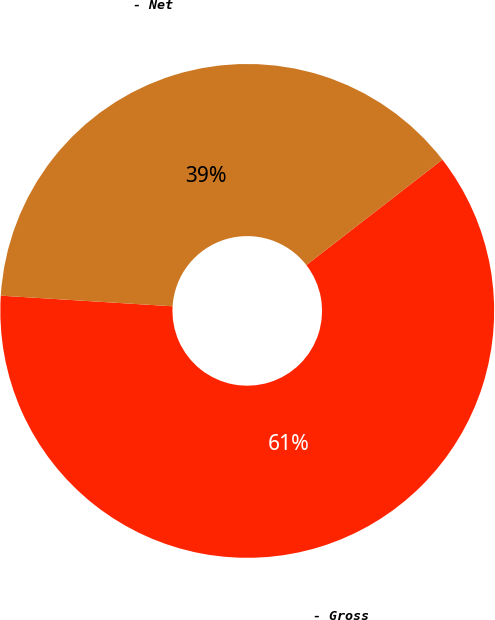Convert chart to OTSL. <chart><loc_0><loc_0><loc_500><loc_500><pie_chart><fcel>- Gross<fcel>- Net<nl><fcel>61.48%<fcel>38.52%<nl></chart> 